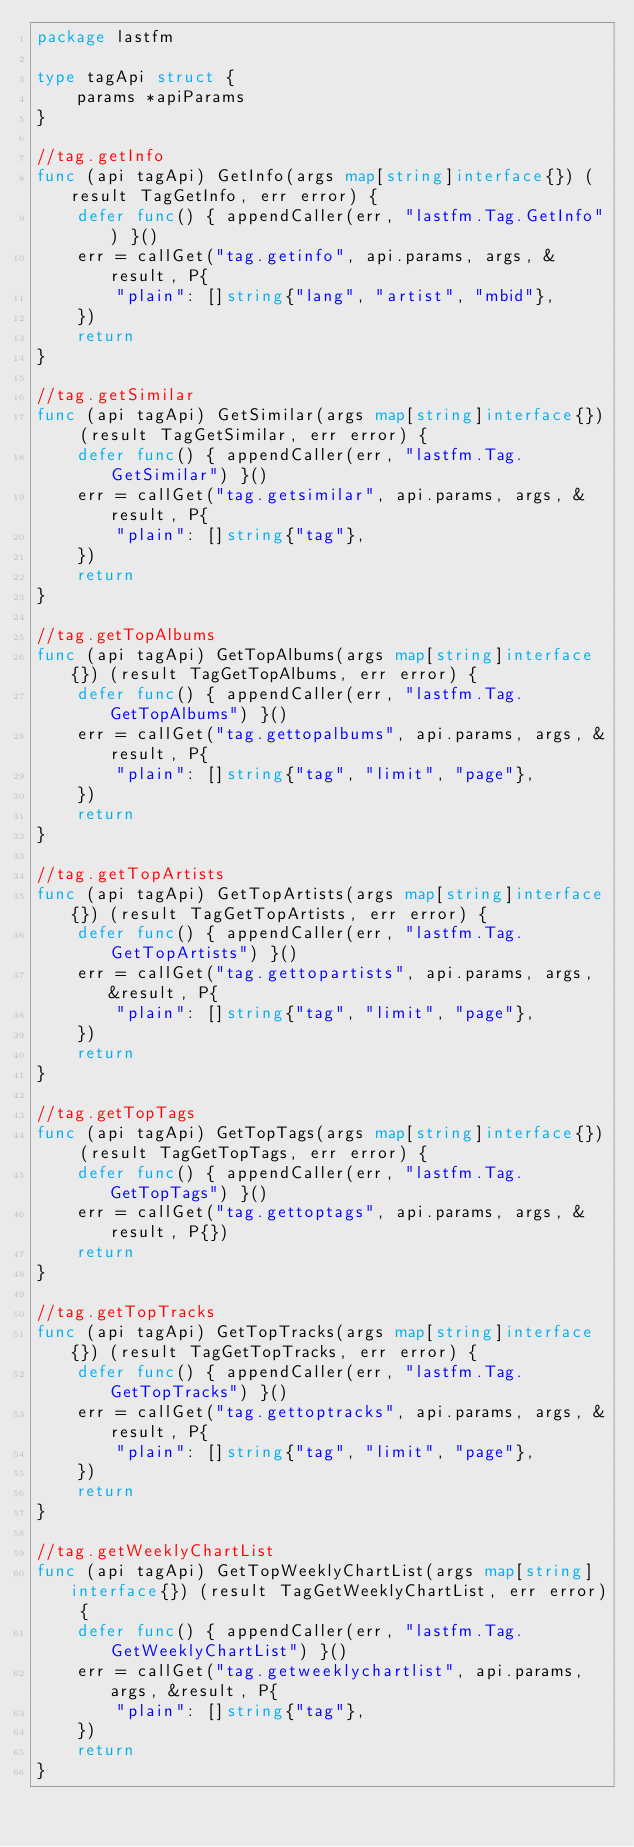Convert code to text. <code><loc_0><loc_0><loc_500><loc_500><_Go_>package lastfm

type tagApi struct {
	params *apiParams
}

//tag.getInfo
func (api tagApi) GetInfo(args map[string]interface{}) (result TagGetInfo, err error) {
	defer func() { appendCaller(err, "lastfm.Tag.GetInfo") }()
	err = callGet("tag.getinfo", api.params, args, &result, P{
		"plain": []string{"lang", "artist", "mbid"},
	})
	return
}

//tag.getSimilar
func (api tagApi) GetSimilar(args map[string]interface{}) (result TagGetSimilar, err error) {
	defer func() { appendCaller(err, "lastfm.Tag.GetSimilar") }()
	err = callGet("tag.getsimilar", api.params, args, &result, P{
		"plain": []string{"tag"},
	})
	return
}

//tag.getTopAlbums
func (api tagApi) GetTopAlbums(args map[string]interface{}) (result TagGetTopAlbums, err error) {
	defer func() { appendCaller(err, "lastfm.Tag.GetTopAlbums") }()
	err = callGet("tag.gettopalbums", api.params, args, &result, P{
		"plain": []string{"tag", "limit", "page"},
	})
	return
}

//tag.getTopArtists
func (api tagApi) GetTopArtists(args map[string]interface{}) (result TagGetTopArtists, err error) {
	defer func() { appendCaller(err, "lastfm.Tag.GetTopArtists") }()
	err = callGet("tag.gettopartists", api.params, args, &result, P{
		"plain": []string{"tag", "limit", "page"},
	})
	return
}

//tag.getTopTags
func (api tagApi) GetTopTags(args map[string]interface{}) (result TagGetTopTags, err error) {
	defer func() { appendCaller(err, "lastfm.Tag.GetTopTags") }()
	err = callGet("tag.gettoptags", api.params, args, &result, P{})
	return
}

//tag.getTopTracks
func (api tagApi) GetTopTracks(args map[string]interface{}) (result TagGetTopTracks, err error) {
	defer func() { appendCaller(err, "lastfm.Tag.GetTopTracks") }()
	err = callGet("tag.gettoptracks", api.params, args, &result, P{
		"plain": []string{"tag", "limit", "page"},
	})
	return
}

//tag.getWeeklyChartList
func (api tagApi) GetTopWeeklyChartList(args map[string]interface{}) (result TagGetWeeklyChartList, err error) {
	defer func() { appendCaller(err, "lastfm.Tag.GetWeeklyChartList") }()
	err = callGet("tag.getweeklychartlist", api.params, args, &result, P{
		"plain": []string{"tag"},
	})
	return
}
</code> 